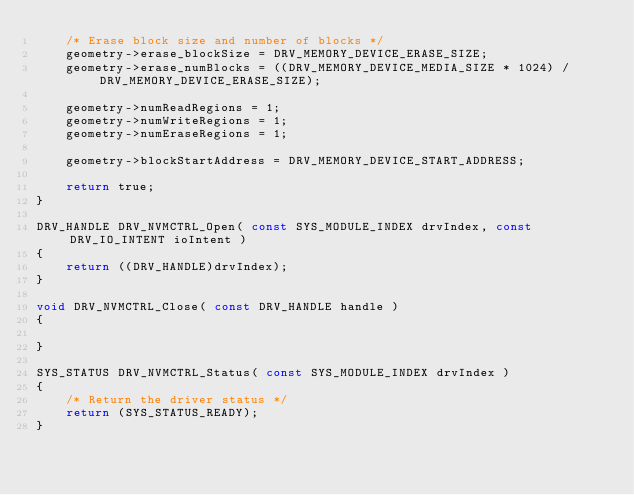<code> <loc_0><loc_0><loc_500><loc_500><_C_>    /* Erase block size and number of blocks */
    geometry->erase_blockSize = DRV_MEMORY_DEVICE_ERASE_SIZE;
    geometry->erase_numBlocks = ((DRV_MEMORY_DEVICE_MEDIA_SIZE * 1024) / DRV_MEMORY_DEVICE_ERASE_SIZE);

    geometry->numReadRegions = 1;
    geometry->numWriteRegions = 1;
    geometry->numEraseRegions = 1;

    geometry->blockStartAddress = DRV_MEMORY_DEVICE_START_ADDRESS;

    return true;
}

DRV_HANDLE DRV_NVMCTRL_Open( const SYS_MODULE_INDEX drvIndex, const DRV_IO_INTENT ioIntent )
{
    return ((DRV_HANDLE)drvIndex);
}

void DRV_NVMCTRL_Close( const DRV_HANDLE handle )
{

}

SYS_STATUS DRV_NVMCTRL_Status( const SYS_MODULE_INDEX drvIndex )
{
    /* Return the driver status */
    return (SYS_STATUS_READY);
}
</code> 